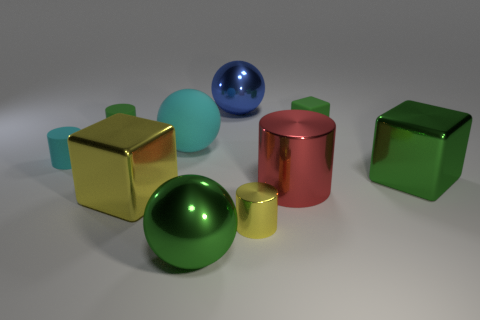What number of other objects are the same shape as the large cyan rubber object?
Give a very brief answer. 2. What material is the other block that is the same color as the tiny block?
Offer a very short reply. Metal. What number of large metal balls are the same color as the small shiny cylinder?
Keep it short and to the point. 0. What is the color of the other ball that is the same material as the green ball?
Ensure brevity in your answer.  Blue. Are there any yellow cubes that have the same size as the cyan rubber ball?
Give a very brief answer. Yes. Is the number of big matte objects that are on the left side of the blue metal thing greater than the number of big cyan matte balls that are in front of the large red cylinder?
Give a very brief answer. Yes. Are the green object to the left of the large green sphere and the small green thing that is right of the blue sphere made of the same material?
Make the answer very short. Yes. The yellow object that is the same size as the green metal cube is what shape?
Provide a short and direct response. Cube. Are there any small green rubber objects that have the same shape as the big yellow metal thing?
Keep it short and to the point. Yes. Do the shiny cube that is on the left side of the big cyan matte thing and the tiny cylinder that is on the right side of the tiny green matte cylinder have the same color?
Offer a very short reply. Yes. 